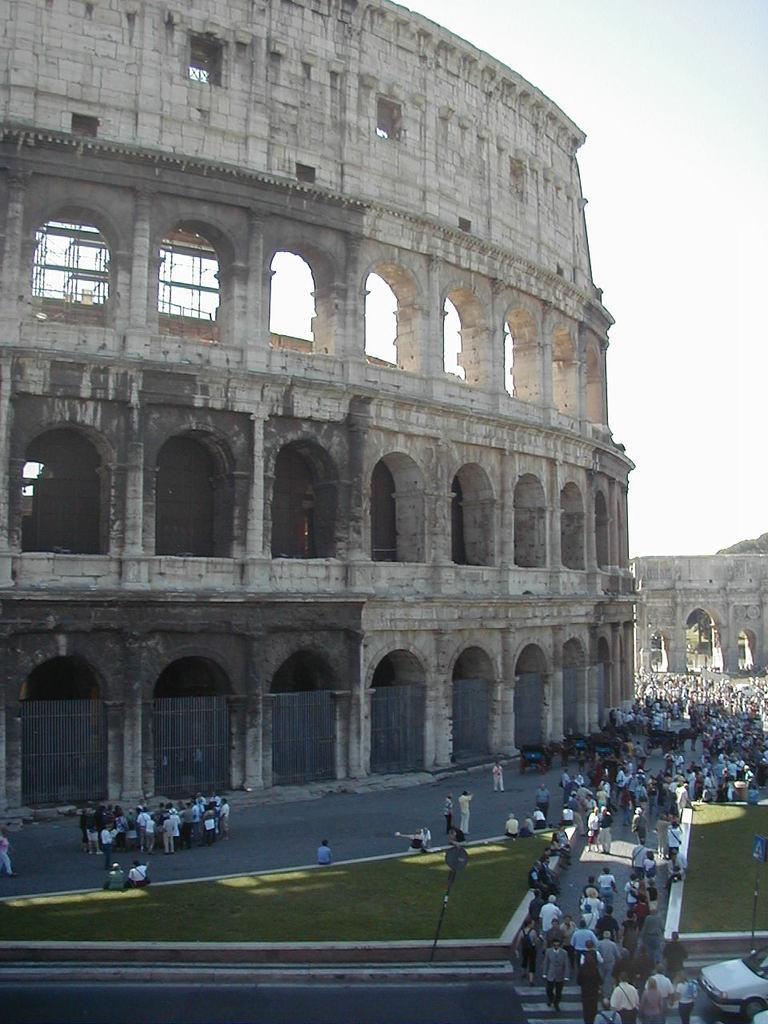Describe this image in one or two sentences. In this Image I can see the group of people with different color dresses. To the side of these people I can see the railing and the fort. I can also see the vehicle to the right. In the back there is a sky. 